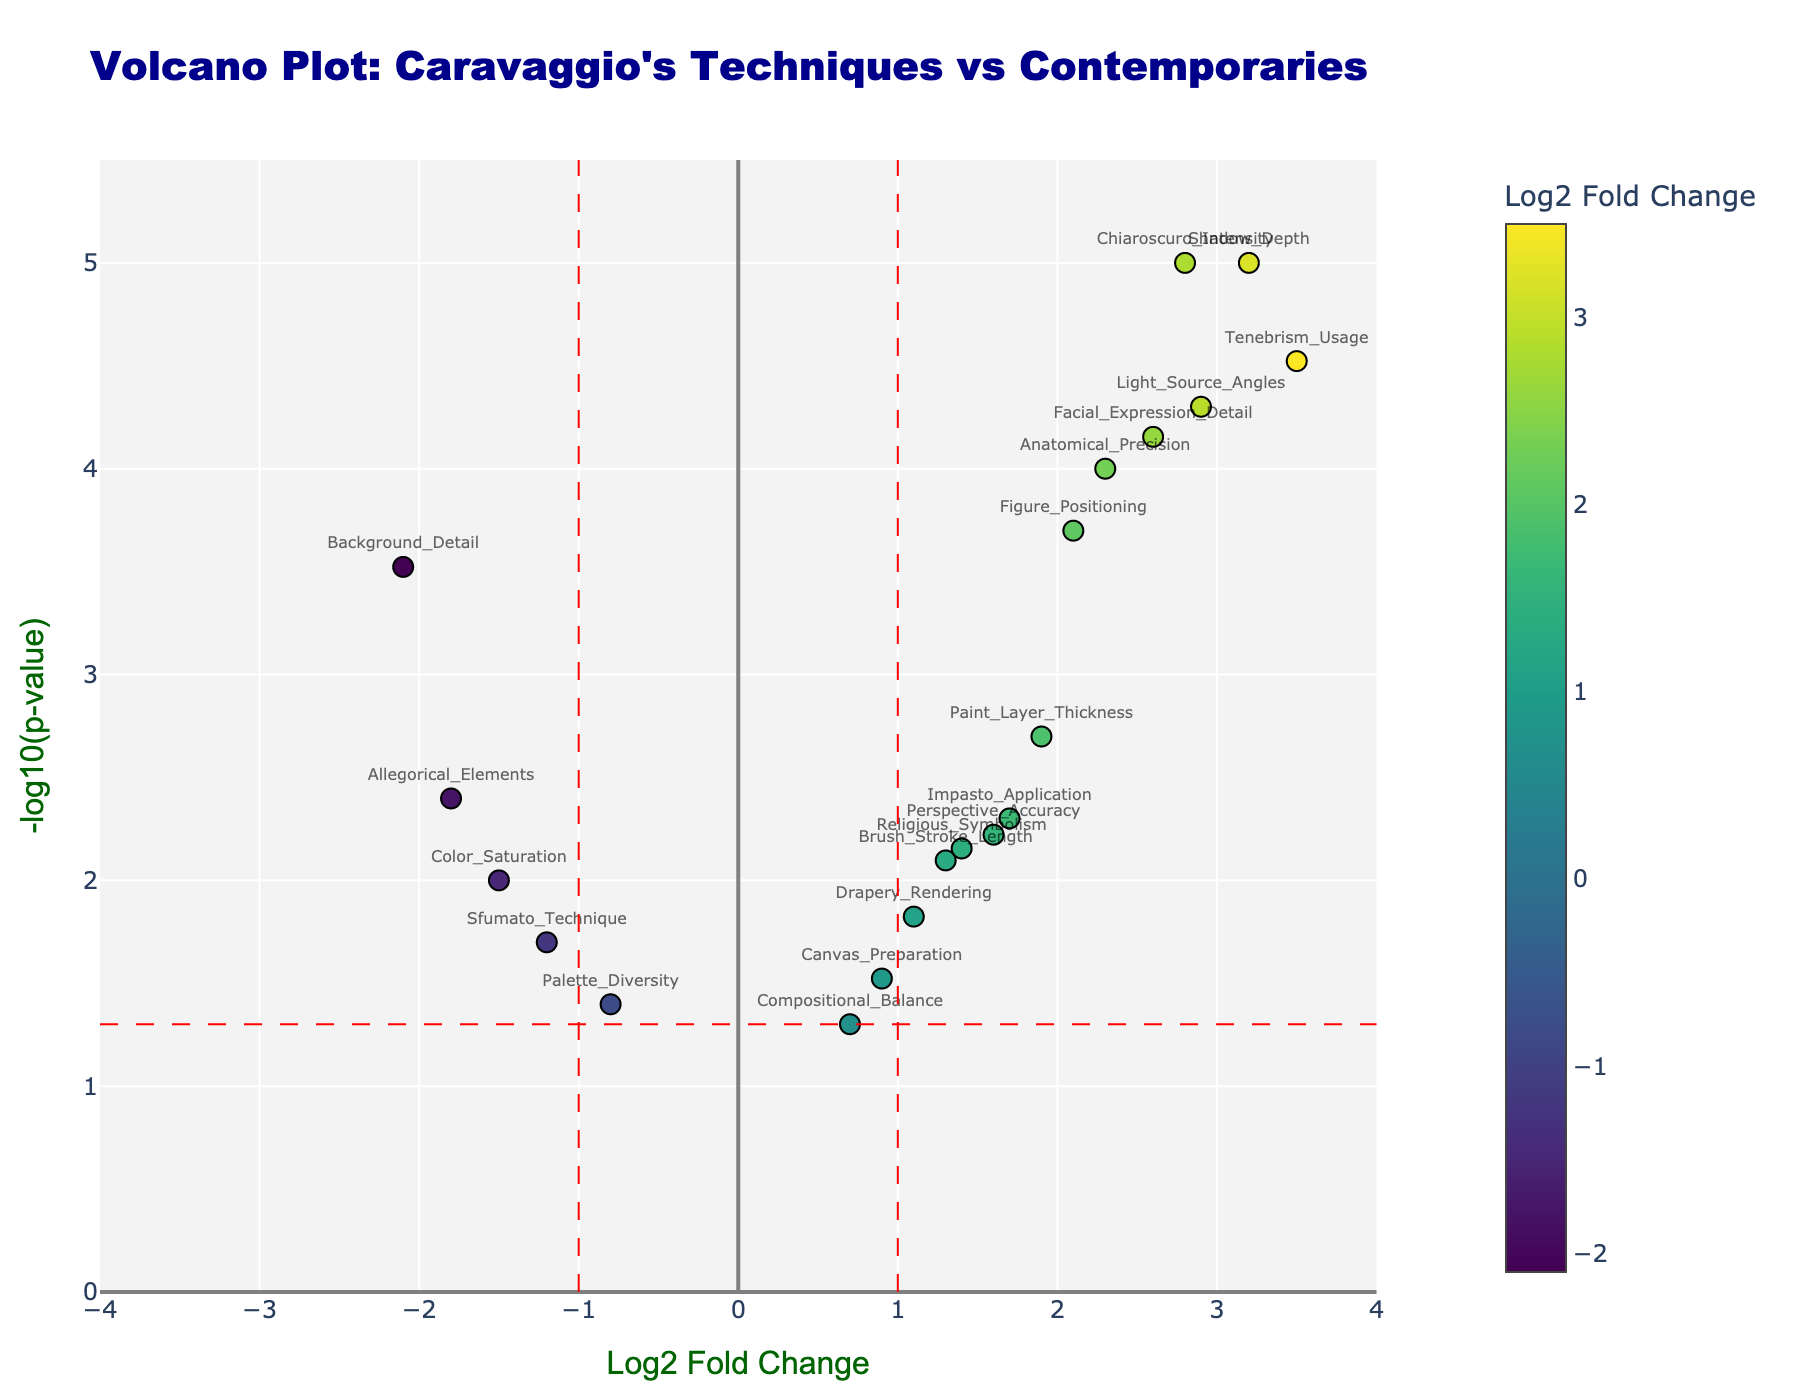Which technique has the highest -log10(p-value)? Look for the point that is highest on the vertical axis; the vertical axis represents -log10(p-value), and the highest point corresponds to the highest value.
Answer: Tenebrism_Usage What are the genes with a Log2 Fold Change greater than 2? Observe the data points to the right of the vertical line marked at Log2 Fold Change = 2. These points indicate genes with Log2 Fold Change greater than this threshold.
Answer: Chiaroscuro_Intensity, Tenebrism_Usage, Figure_Positioning, Light_Source_Angles, Shadow_Depth, Facial_Expression_Detail, Anatomical_Precision Which gene shows the least significant p-value while having a negative Log2 Fold Change? Look among the points on the left side of the zero line (negative Log2 Fold Change) and at the bottom of the y-axis (-log10(p-value)). The least significant p-value will have the lowest -log10(p-value).
Answer: Palette_Diversity What is the Log2 Fold Change threshold indicated by the vertical dashed lines? The question asks for the numerical value at which the vertical dashed lines intersect the x-axis. These lines indicate specific thresholds in Log2 Fold Change.
Answer: ±1 Which gene shows the greatest deviation in terms of Log2 Fold Change and is significantly different with a high -log10(p-value)? Identify the data point that is furthest to the left or right (indicating extreme Log2 Fold Change) and is significantly above the -log10(p-value) threshold line.
Answer: Tenebrism_Usage How many data points have a p-value less than 0.05? Count all the points above the horizontal dashed line representing the -log10(0.05) threshold.
Answer: 16 What are the genes with Log2 Fold Change less than -1 and -log10(p-value) higher than 1.3? Look for data points left of the dashed -1 line (Log2 Fold Change < -1) and above the value 1.3 on the y-axis (-log10(p-value)). These data points satisfy both conditions.
Answer: Allegorical_Elements, Background_Detail 